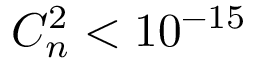Convert formula to latex. <formula><loc_0><loc_0><loc_500><loc_500>C _ { n } ^ { 2 } < 1 0 ^ { - 1 5 }</formula> 